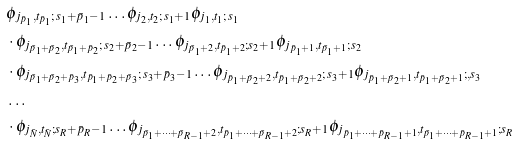Convert formula to latex. <formula><loc_0><loc_0><loc_500><loc_500>& \phi _ { j _ { \bar { p } _ { 1 } } , t _ { \bar { p } _ { 1 } } ; \, s _ { 1 } + \bar { p } _ { 1 } - 1 } \dots \phi _ { j _ { 2 } , t _ { 2 } ; \, s _ { 1 } + 1 } \phi _ { j _ { 1 } , t _ { 1 } ; \, s _ { 1 } } \\ & \cdot \phi _ { j _ { \bar { p } _ { 1 } + \bar { p } _ { 2 } } , t _ { \bar { p } _ { 1 } + \bar { p } _ { 2 } } ; \, s _ { 2 } + \bar { p } _ { 2 } - 1 } \dots \phi _ { j _ { \bar { p } _ { 1 } + 2 } , t _ { \bar { p } _ { 1 } + 2 } ; s _ { 2 } + 1 } \phi _ { j _ { \bar { p } _ { 1 } + 1 } , t _ { \bar { p } _ { 1 } + 1 } ; \, s _ { 2 } } \\ & \cdot \phi _ { j _ { \bar { p } _ { 1 } + \bar { p } _ { 2 } + \bar { p } _ { 3 } } , t _ { \bar { p } _ { 1 } + \bar { p } _ { 2 } + \bar { p } _ { 3 } } ; \, s _ { 3 } + \bar { p } _ { 3 } - 1 } \dots \phi _ { j _ { \bar { p } _ { 1 } + \bar { p } _ { 2 } + 2 } , t _ { \bar { p } _ { 1 } + \bar { p } _ { 2 } + 2 } ; \, s _ { 3 } + 1 } \phi _ { j _ { \bar { p } _ { 1 } + \bar { p } _ { 2 } + 1 } , t _ { \bar { p } _ { 1 } + \bar { p } _ { 2 } + 1 } ; , s _ { 3 } } \\ & \dots \\ & \cdot \phi _ { j _ { \bar { N } } , t _ { \bar { N } } ; s _ { R } + \bar { p } _ { R } - 1 } \dots \phi _ { j _ { \bar { p } _ { 1 } + \dots + \bar { p } _ { R - 1 } + 2 } , t _ { \bar { p } _ { 1 } + \dots + \bar { p } _ { R - 1 } + 2 } ; s _ { R } + 1 } \phi _ { j _ { \bar { p } _ { 1 } + \dots + \bar { p } _ { R - 1 } + 1 } , t _ { \bar { p } _ { 1 } + \dots + \bar { p } _ { R - 1 } + 1 } ; s _ { R } }</formula> 